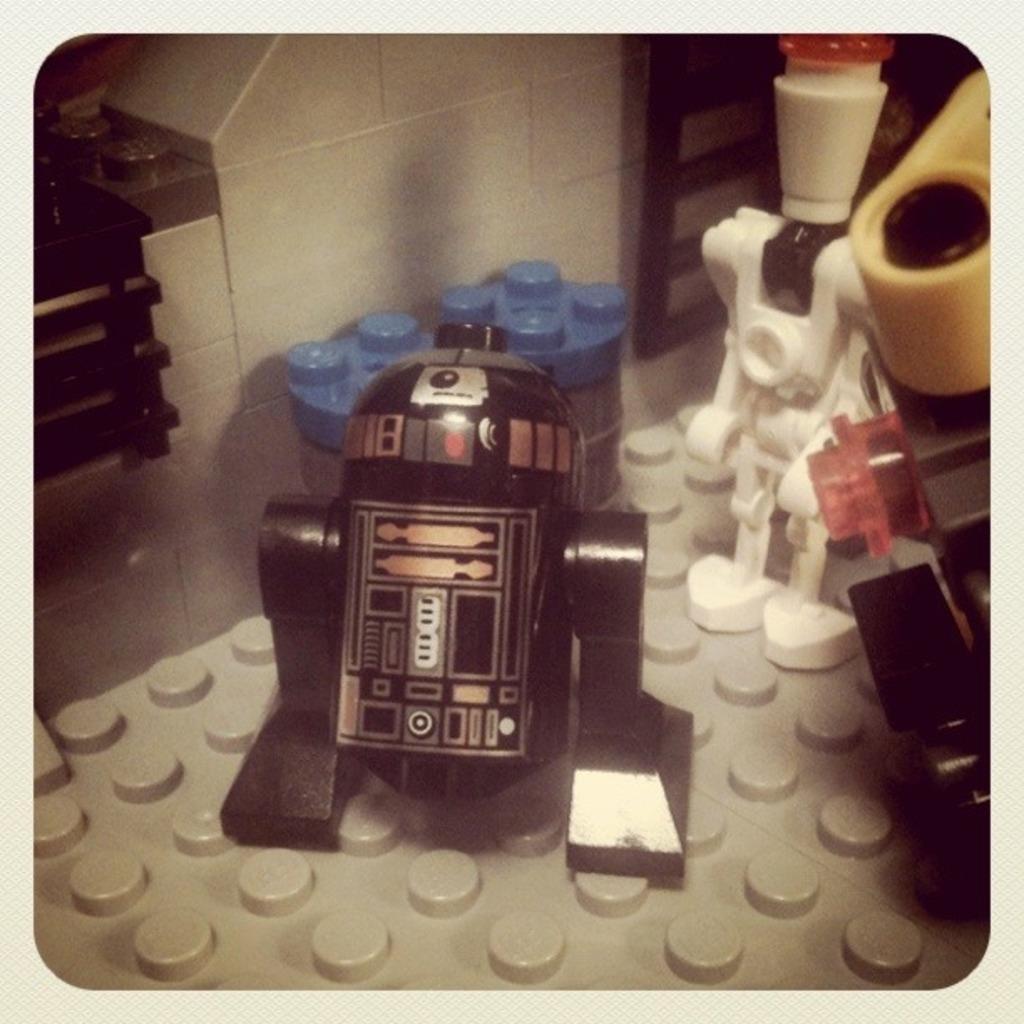Can you describe this image briefly? In this picture I can see in the middle there is a toy in black color, on the right side there is another toy in white color. At the bottom there is the plastic thing in grey color. 